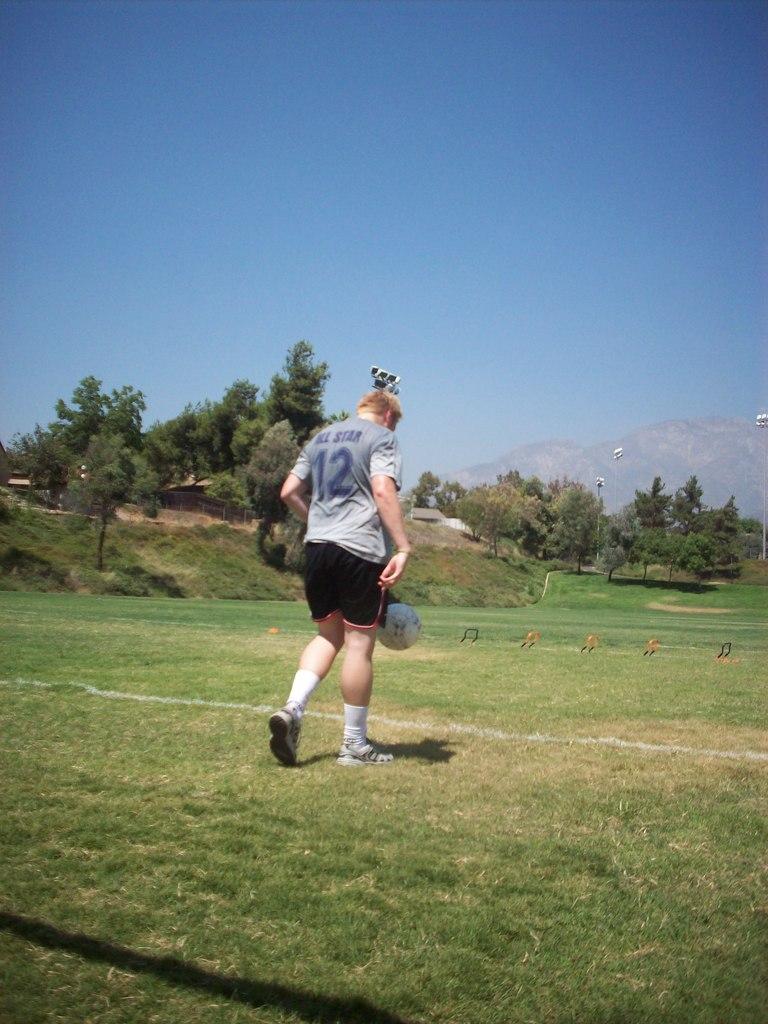What number is he?
Ensure brevity in your answer.  12. 